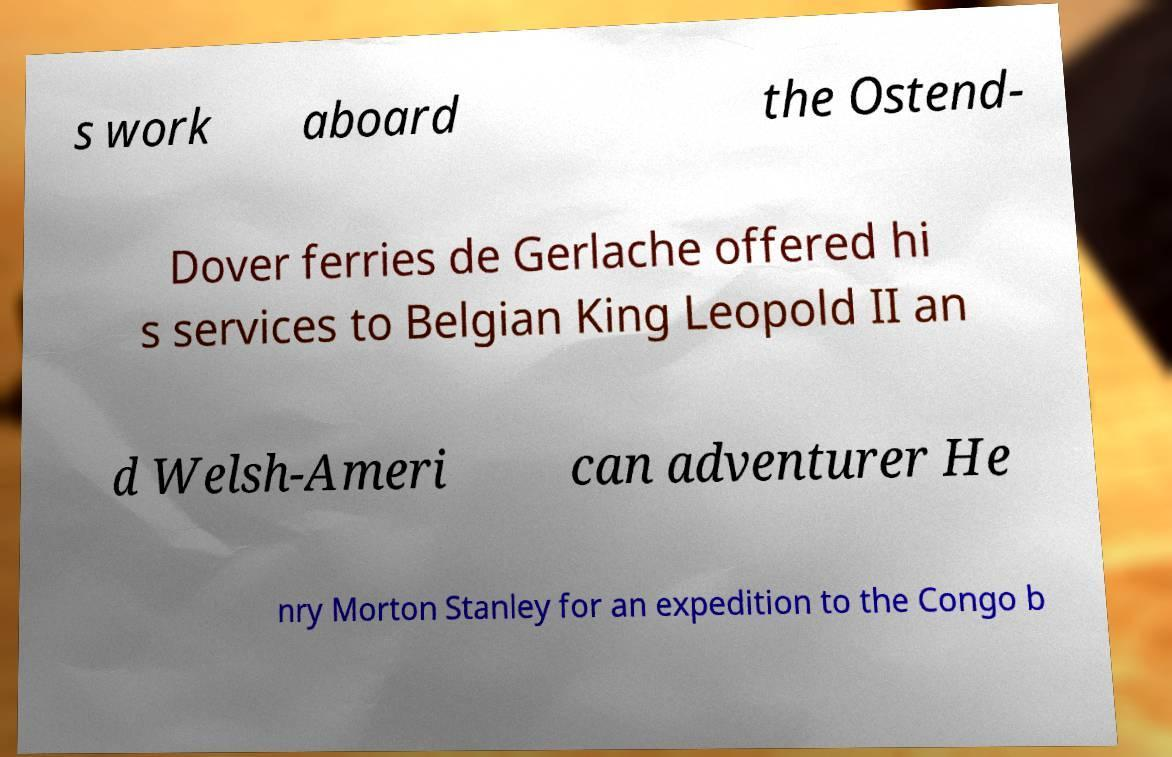Could you extract and type out the text from this image? s work aboard the Ostend- Dover ferries de Gerlache offered hi s services to Belgian King Leopold II an d Welsh-Ameri can adventurer He nry Morton Stanley for an expedition to the Congo b 